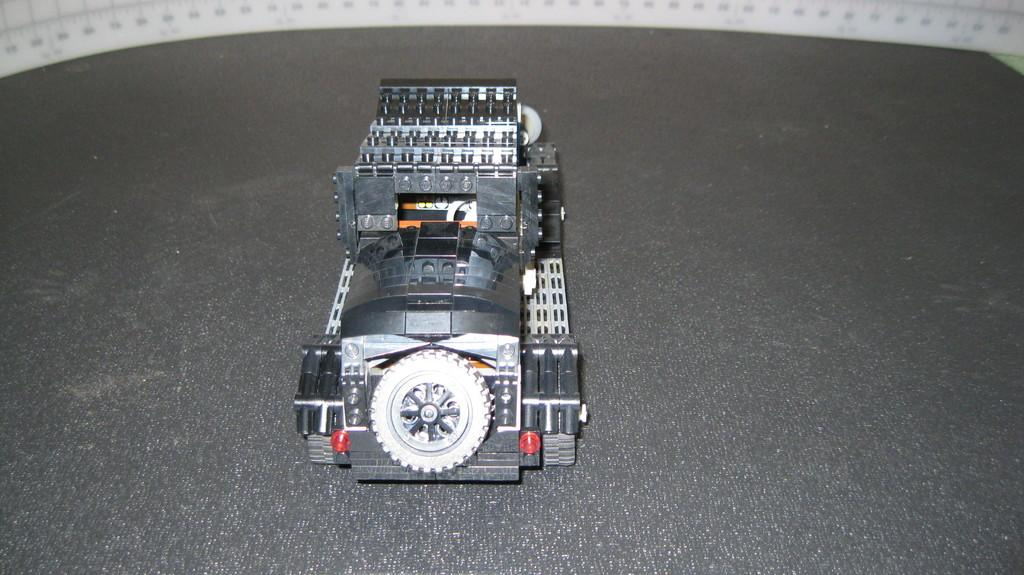What type of toy is on the floor in the image? There is a toy train on the floor. Can you describe any other objects in the image? In the background of the image, there is a measuring tape. What type of muscle is being exercised by the toy train in the image? There is no muscle being exercised by the toy train in the image, as it is an inanimate object. 